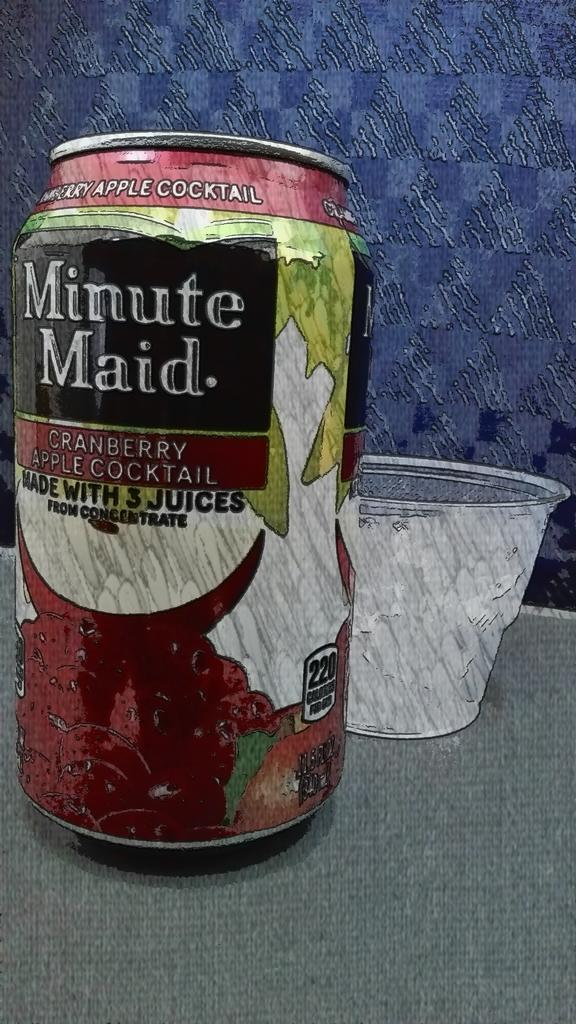Provide a one-sentence caption for the provided image. a Minute Maid cranberry apple cocktail in a can. 